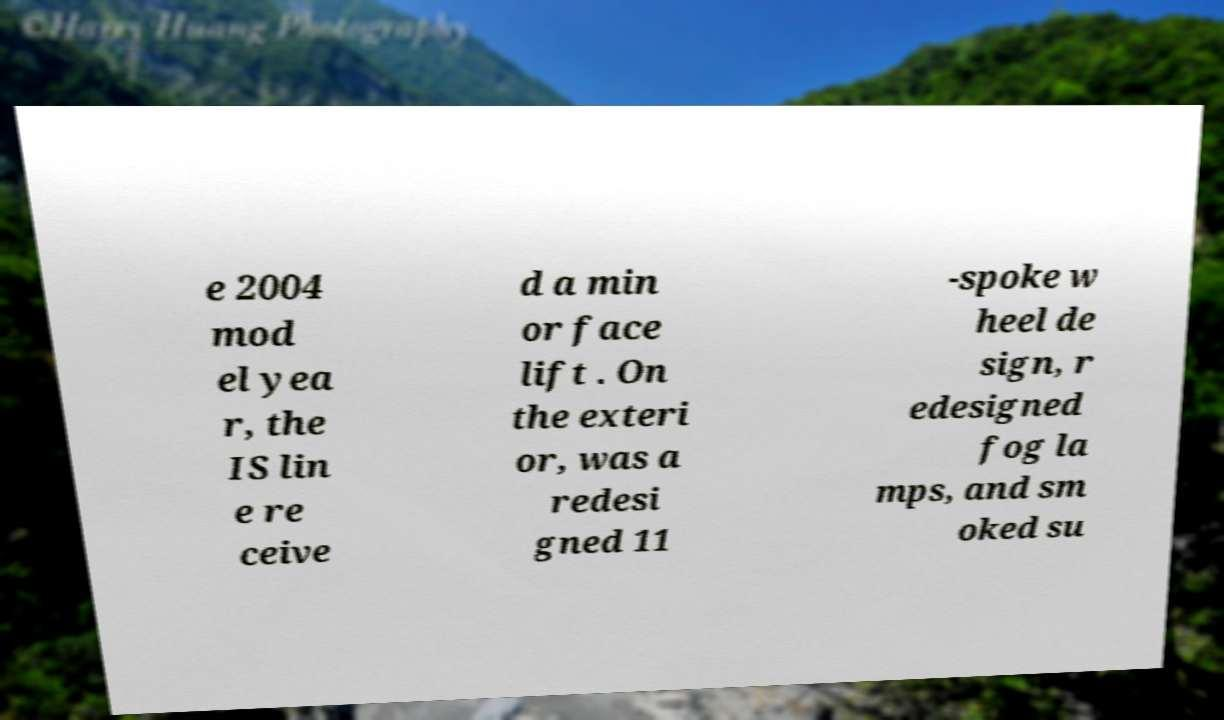There's text embedded in this image that I need extracted. Can you transcribe it verbatim? e 2004 mod el yea r, the IS lin e re ceive d a min or face lift . On the exteri or, was a redesi gned 11 -spoke w heel de sign, r edesigned fog la mps, and sm oked su 